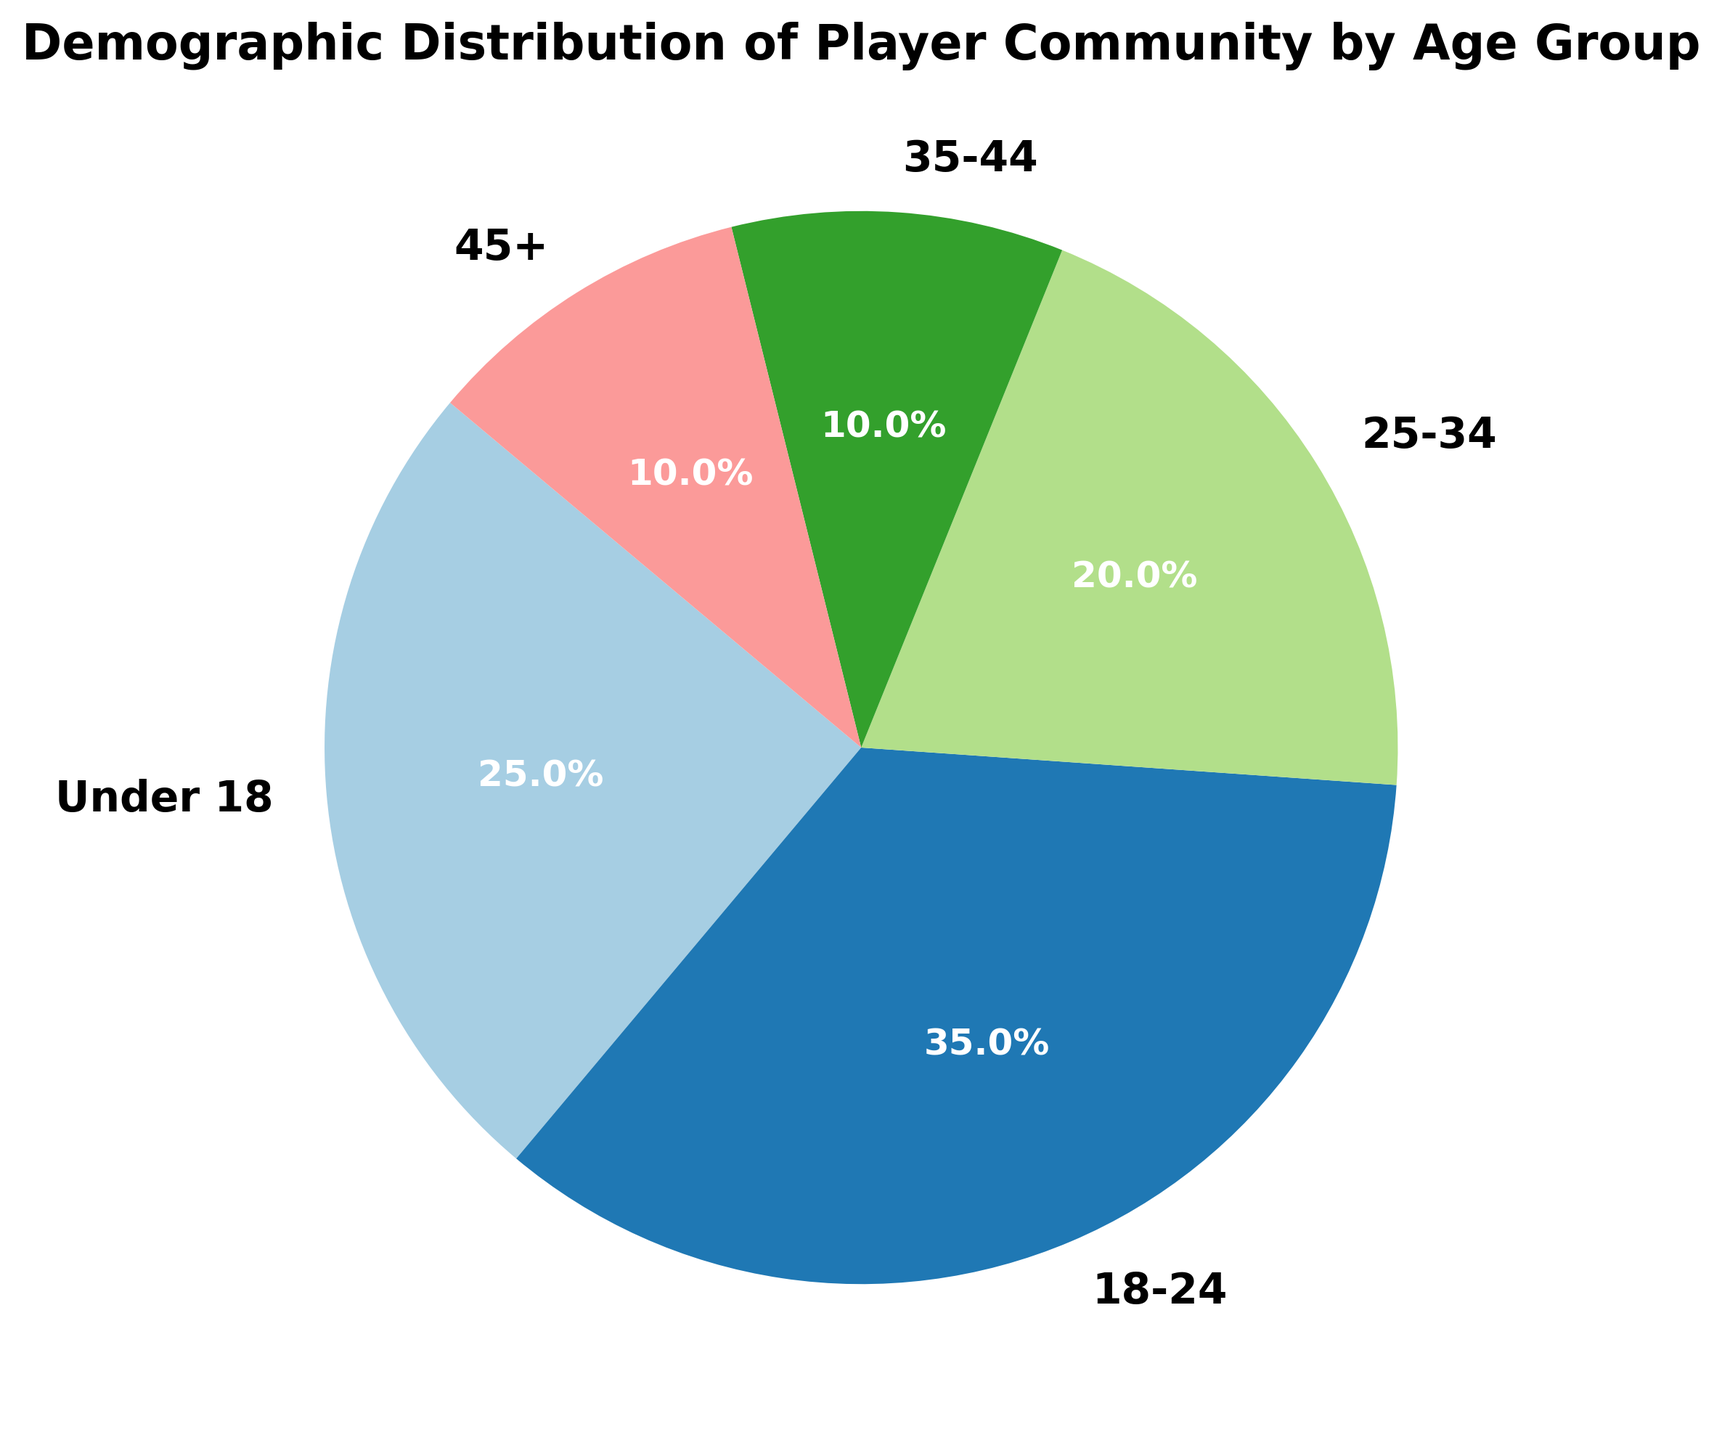What percentage of the player community is under 24 years old? The under 24 years age group includes 'Under 18' and '18-24'. Sum their percentages: 25% + 35% = 60%.
Answer: 60% Which age group has the highest percentage? By examining the pie chart, the '18-24' age group has the highest value at 35%.
Answer: 18-24 What is the difference in percentage between the 18-24 age group and the 25-34 age group? Subtract the percentage of the 25-34 age group (20%) from the 18-24 age group (35%): 35% - 20% = 15%.
Answer: 15% Are there any age groups with the same percentage? By inspecting the values, the '35-44' and '45+' age groups both have 10%.
Answer: Yes What portion of the player community is 35 years old or older? Sum the percentages of the '35-44' and '45+' age groups: 10% + 10% = 20%.
Answer: 20% If we combined the percentages of the 25-34 age group and the 35-44 age group, how would it compare to the Under 18 age group? Sum the percentages of the 25-34 and 35-44 age groups: 20% + 10% = 30%. The Under 18 age group is 25%. 30% > 25%.
Answer: Greater Which color represents the 'Under 18' age group? The plot uses a colormap for unique colors, and visually, the 'Under 18' group is represented by a distinct color. Check the color in the pie chart.
Answer: (Answer will depend on the specific chart visualization.) How much more in percentage is the '18-24' age group compared to the '45+' age group? Subtract the '45+' group percentage (10%) from the '18-24' group (35%): 35% - 10% = 25%.
Answer: 25% What is the sum of the percentages of all age groups? Add all the percentages together: 25% + 35% + 20% + 10% + 10% = 100%.
Answer: 100% What is the average percentage of the 25-34, 35-44, and 45+ age groups combined? Sum the percentages of the 25-34, 35-44, and 45+ age groups: 20% + 10% + 10% = 40%. Divide by the number of groups: 40% / 3 ≈ 13.33%.
Answer: 13.33% 